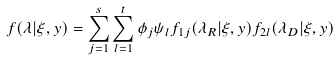<formula> <loc_0><loc_0><loc_500><loc_500>f ( \lambda | \xi , y ) = \sum _ { j = 1 } ^ { s } \sum _ { l = 1 } ^ { t } \phi _ { j } \psi _ { l } f _ { 1 j } ( \lambda _ { R } | \xi , y ) f _ { 2 l } ( \lambda _ { D } | \xi , y )</formula> 